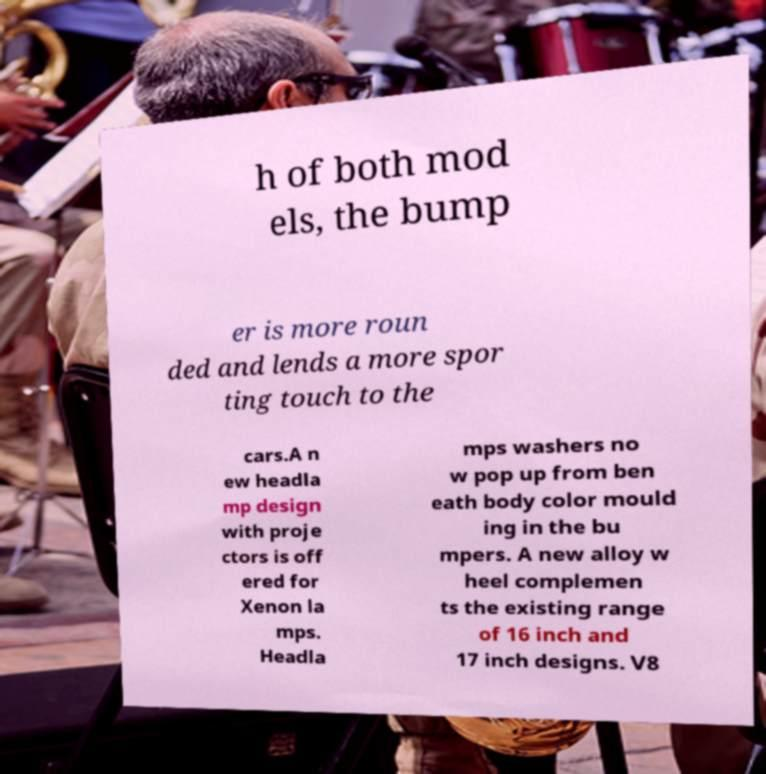Could you assist in decoding the text presented in this image and type it out clearly? h of both mod els, the bump er is more roun ded and lends a more spor ting touch to the cars.A n ew headla mp design with proje ctors is off ered for Xenon la mps. Headla mps washers no w pop up from ben eath body color mould ing in the bu mpers. A new alloy w heel complemen ts the existing range of 16 inch and 17 inch designs. V8 